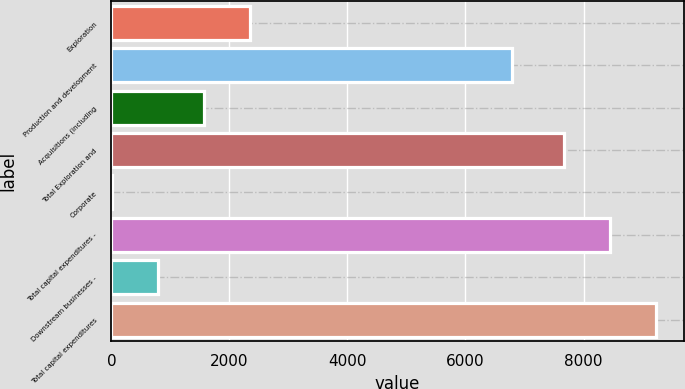Convert chart to OTSL. <chart><loc_0><loc_0><loc_500><loc_500><bar_chart><fcel>Exploration<fcel>Production and development<fcel>Acquisitions (including<fcel>Total Exploration and<fcel>Corporate<fcel>Total capital expenditures -<fcel>Downstream businesses -<fcel>Total capital expenditures<nl><fcel>2342.7<fcel>6790<fcel>1563.8<fcel>7676<fcel>6<fcel>8454.9<fcel>784.9<fcel>9233.8<nl></chart> 